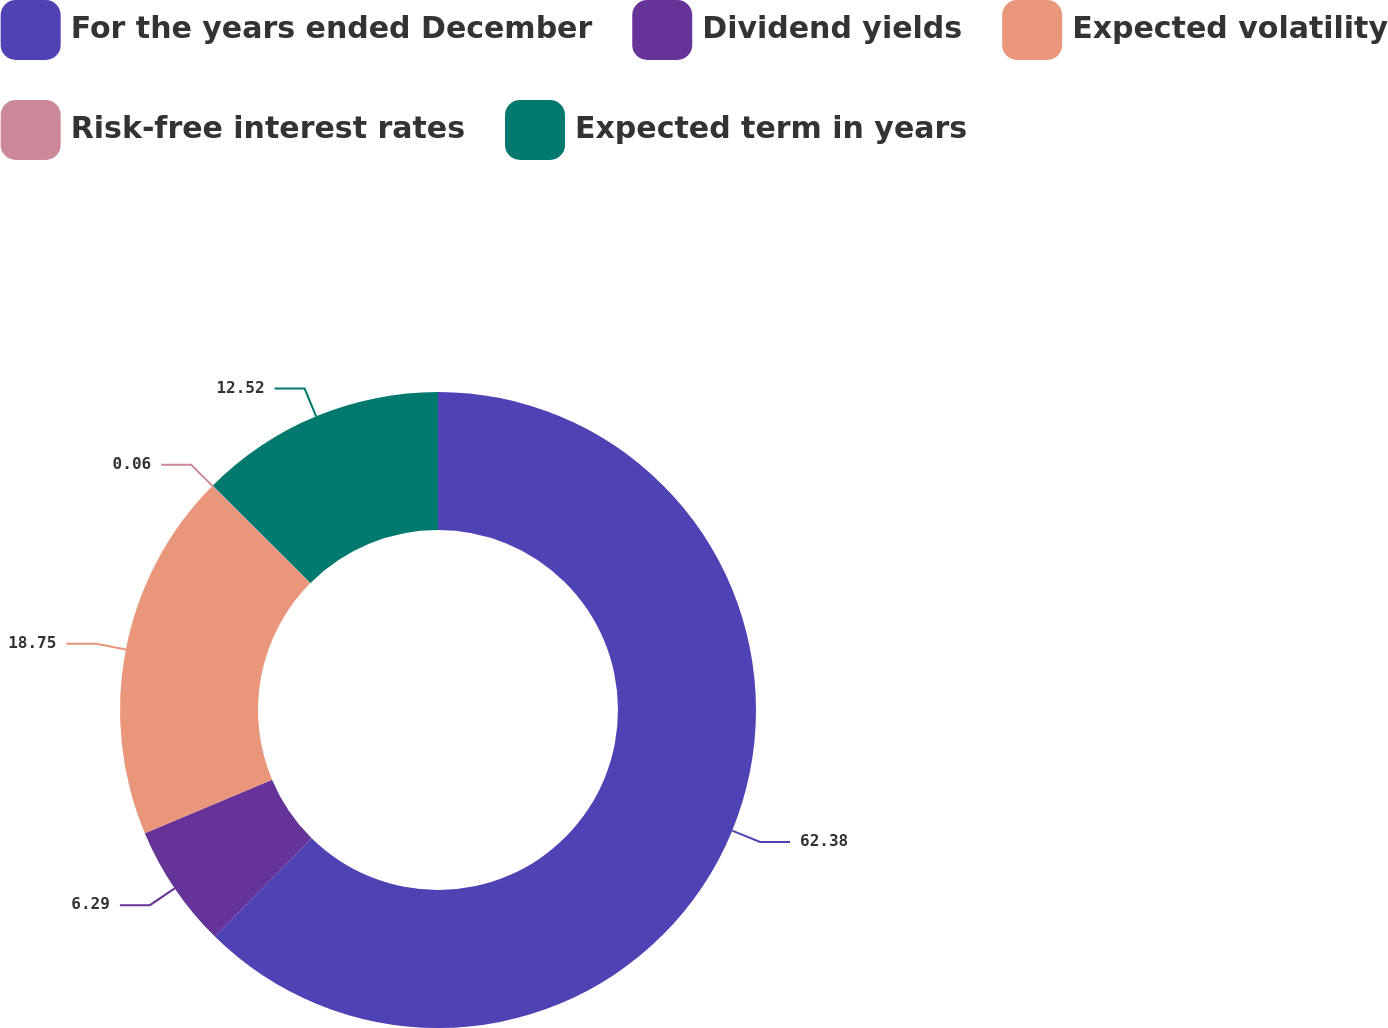Convert chart to OTSL. <chart><loc_0><loc_0><loc_500><loc_500><pie_chart><fcel>For the years ended December<fcel>Dividend yields<fcel>Expected volatility<fcel>Risk-free interest rates<fcel>Expected term in years<nl><fcel>62.38%<fcel>6.29%<fcel>18.75%<fcel>0.06%<fcel>12.52%<nl></chart> 